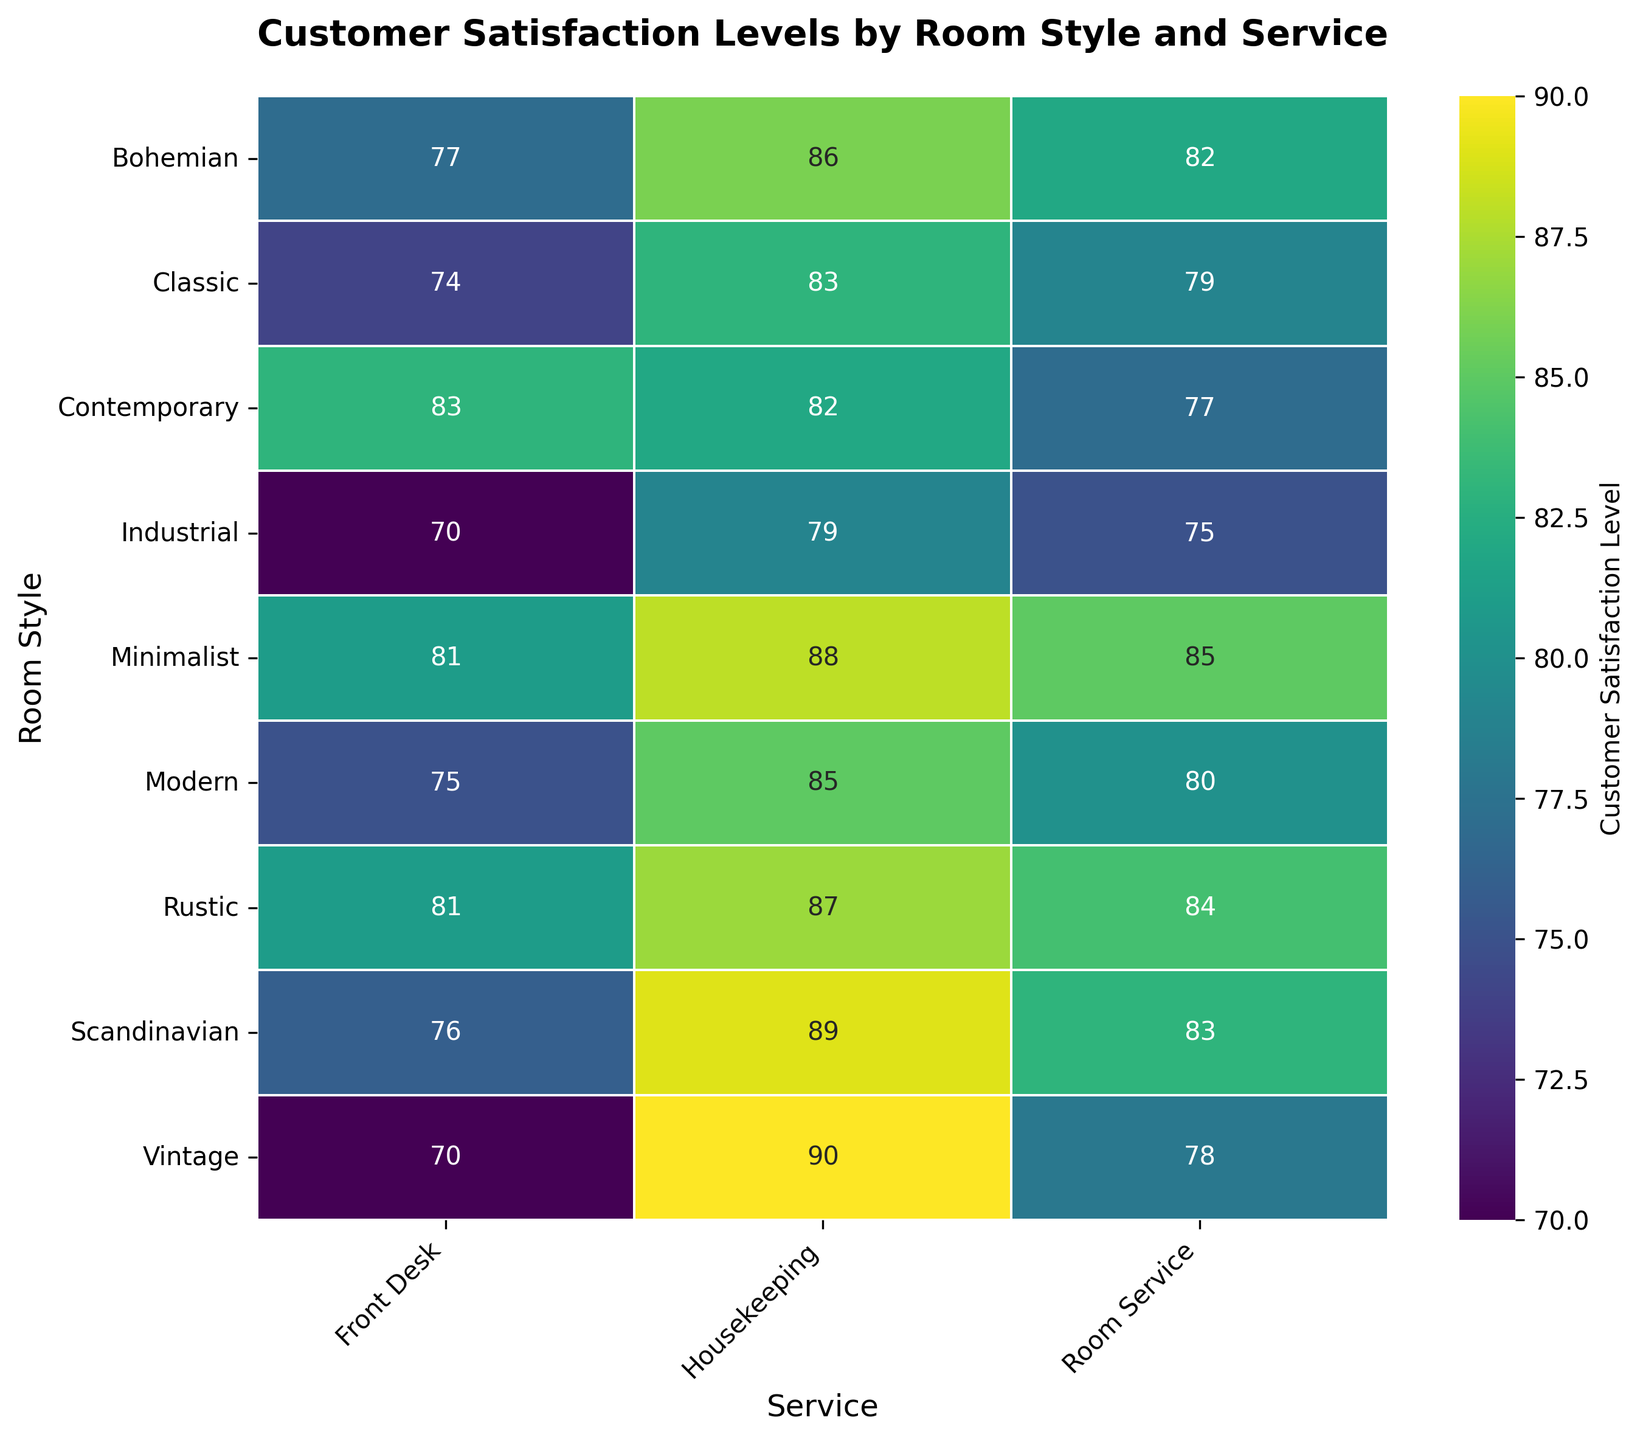What is the highest customer satisfaction level for any room style and service combination? To find the highest satisfaction level, scan through all the numbers in the heatmap. The highest value is 90, which corresponds to the Vintage room style for Housekeeping service.
Answer: 90 Which room style has the lowest customer satisfaction level for Room Service? Focus on the Room Service column. The lowest number in this column is 75, which corresponds to the Industrial room style.
Answer: Industrial What is the difference in customer satisfaction levels between Housekeeping and Room Service for the Bohemian room style? Find the values for Housekeeping and Room Service under the Bohemian row, which are 86 and 82 respectively. The difference is 86 - 82 = 4.
Answer: 4 Which service generally has the highest customer satisfaction level across all room styles? Compare the maximum values in each service column. Housekeeping has the highest values overall, with several satisfaction levels above 85.
Answer: Housekeeping What is the average customer satisfaction level for the Scandinavian room style across all services? For Scandinavian, the satisfaction levels are 89 (Housekeeping), 83 (Room Service), and 76 (Front Desk). The average is (89 + 83 + 76) / 3 = 82.67.
Answer: 82.67 How does the customer satisfaction level for Front Desk service in the Modern room style compare to the same service in the Rustic room style? Find the values for Front Desk under both Modern and Rustic, which are 75 and 81 respectively. The satisfaction level in Rustic is higher by 6 points.
Answer: Rustic is higher by 6 Which room style has the most consistent customer satisfaction levels across all services? Consistent satisfaction levels mean minimal variation. For Minimalist: (88, 85, 81) and Rustic: (87, 84, 81), check other room styles similarly. Minimalist and Rustic show high consistency, but Rustic has tighter grouping if witnessed visually.
Answer: Rustic What is the range of customer satisfaction levels for Modern room styles? For Modern, the satisfaction levels are 85 (Housekeeping), 80 (Room Service), and 75 (Front Desk). The range is 85 - 75 = 10.
Answer: 10 Which room style has a higher customer satisfaction level in Room Service: Classic or Contemporary? Compare the Room Service values for Classic (79) and Contemporary (77). Classic has a higher value.
Answer: Classic 